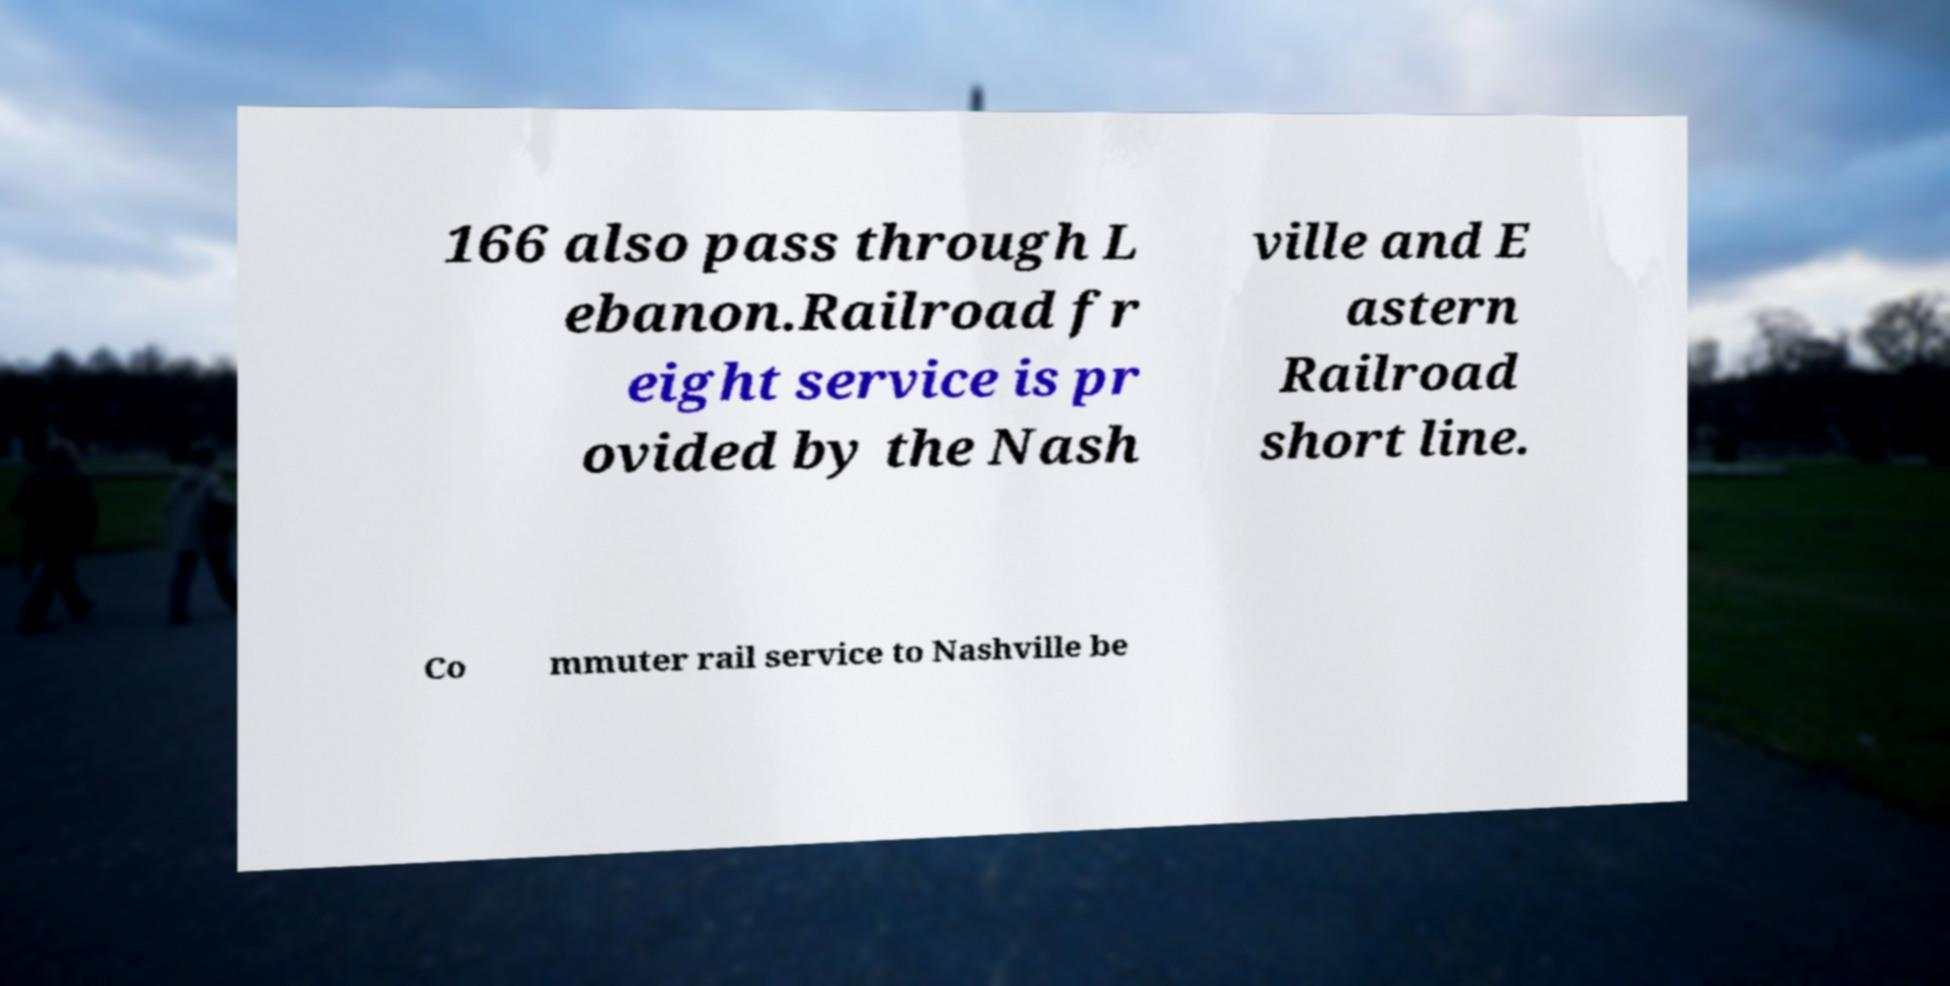Please identify and transcribe the text found in this image. 166 also pass through L ebanon.Railroad fr eight service is pr ovided by the Nash ville and E astern Railroad short line. Co mmuter rail service to Nashville be 